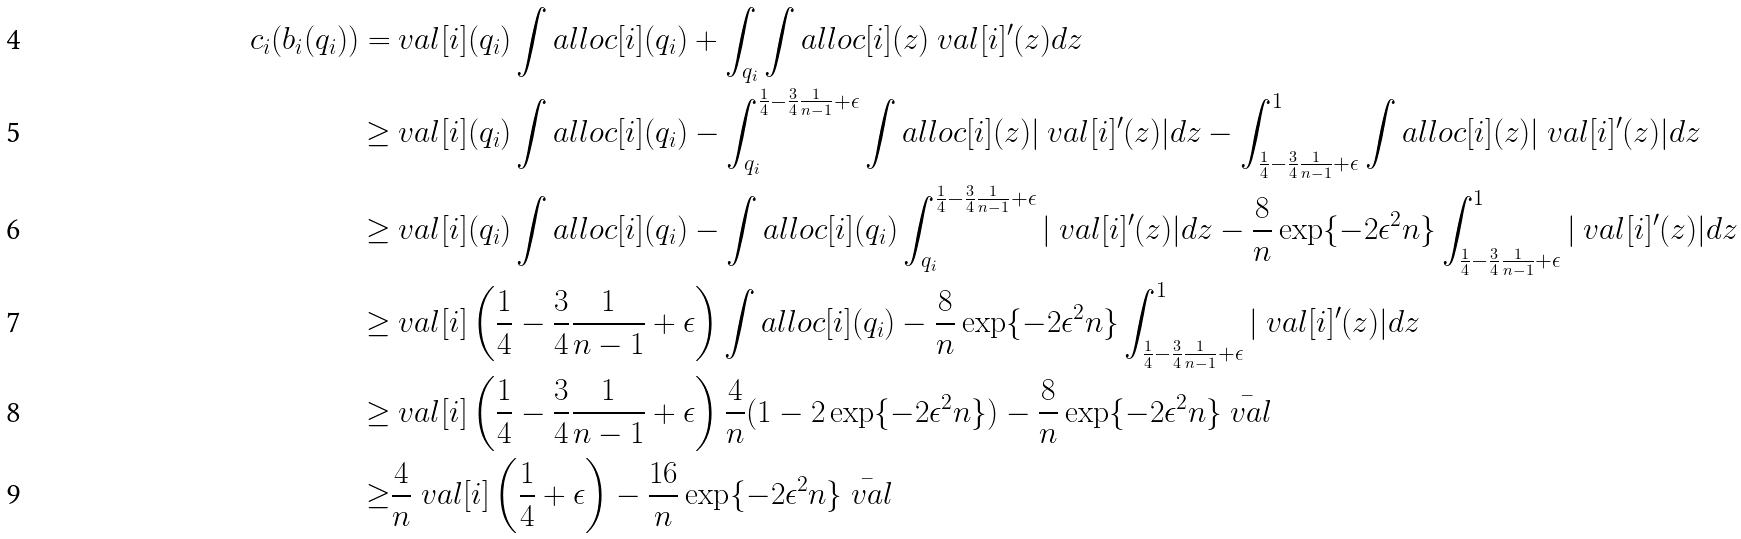Convert formula to latex. <formula><loc_0><loc_0><loc_500><loc_500>c _ { i } ( b _ { i } ( q _ { i } ) ) = & \ v a l [ i ] ( q _ { i } ) \int a l l o c [ i ] ( q _ { i } ) + \int _ { q _ { i } } \int a l l o c [ i ] ( z ) \ v a l [ i ] ^ { \prime } ( z ) d z \\ \geq & \ v a l [ i ] ( q _ { i } ) \int a l l o c [ i ] ( q _ { i } ) - \int _ { q _ { i } } ^ { \frac { 1 } { 4 } - \frac { 3 } { 4 } \frac { 1 } { n - 1 } + \epsilon } \int a l l o c [ i ] ( z ) | \ v a l [ i ] ^ { \prime } ( z ) | d z - \int _ { \frac { 1 } { 4 } - \frac { 3 } { 4 } \frac { 1 } { n - 1 } + \epsilon } ^ { 1 } \int a l l o c [ i ] ( z ) | \ v a l [ i ] ^ { \prime } ( z ) | d z \\ \geq & \ v a l [ i ] ( q _ { i } ) \int a l l o c [ i ] ( q _ { i } ) - \int a l l o c [ i ] ( q _ { i } ) \int _ { q _ { i } } ^ { \frac { 1 } { 4 } - \frac { 3 } { 4 } \frac { 1 } { n - 1 } + \epsilon } | \ v a l [ i ] ^ { \prime } ( z ) | d z - \frac { 8 } { n } \exp \{ - 2 \epsilon ^ { 2 } n \} \int _ { \frac { 1 } { 4 } - \frac { 3 } { 4 } \frac { 1 } { n - 1 } + \epsilon } ^ { 1 } | \ v a l [ i ] ^ { \prime } ( z ) | d z \\ \geq & \ v a l [ i ] \left ( \frac { 1 } { 4 } - \frac { 3 } { 4 } \frac { 1 } { n - 1 } + \epsilon \right ) \int a l l o c [ i ] ( q _ { i } ) - \frac { 8 } { n } \exp \{ - 2 \epsilon ^ { 2 } n \} \int _ { \frac { 1 } { 4 } - \frac { 3 } { 4 } \frac { 1 } { n - 1 } + \epsilon } ^ { 1 } | \ v a l [ i ] ^ { \prime } ( z ) | d z \\ \geq & \ v a l [ i ] \left ( \frac { 1 } { 4 } - \frac { 3 } { 4 } \frac { 1 } { n - 1 } + \epsilon \right ) \frac { 4 } { n } ( 1 - 2 \exp \{ - 2 \epsilon ^ { 2 } n \} ) - \frac { 8 } { n } \exp \{ - 2 \epsilon ^ { 2 } n \} \bar { \ v a l } \\ \geq & \frac { 4 } { n } \ v a l [ i ] \left ( \frac { 1 } { 4 } + \epsilon \right ) - \frac { 1 6 } { n } \exp \{ - 2 \epsilon ^ { 2 } n \} \bar { \ v a l }</formula> 